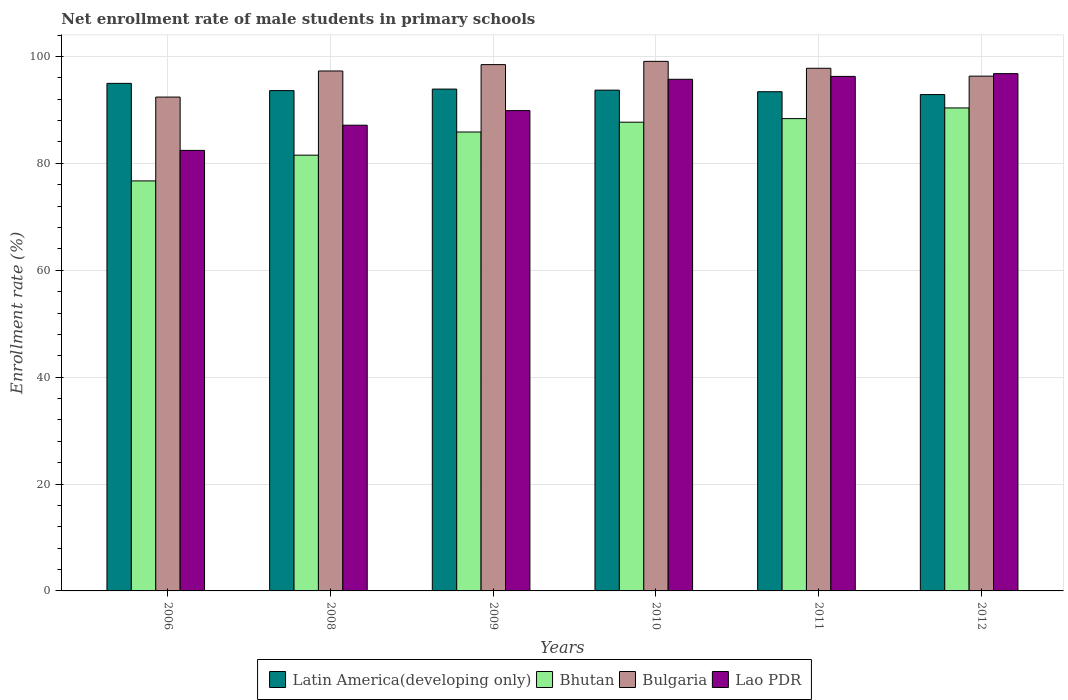How many groups of bars are there?
Your response must be concise. 6. How many bars are there on the 4th tick from the right?
Provide a short and direct response. 4. What is the net enrollment rate of male students in primary schools in Lao PDR in 2012?
Offer a very short reply. 96.79. Across all years, what is the maximum net enrollment rate of male students in primary schools in Bhutan?
Your answer should be compact. 90.37. Across all years, what is the minimum net enrollment rate of male students in primary schools in Lao PDR?
Offer a very short reply. 82.43. In which year was the net enrollment rate of male students in primary schools in Latin America(developing only) maximum?
Provide a short and direct response. 2006. What is the total net enrollment rate of male students in primary schools in Lao PDR in the graph?
Your response must be concise. 548.23. What is the difference between the net enrollment rate of male students in primary schools in Bhutan in 2006 and that in 2012?
Give a very brief answer. -13.65. What is the difference between the net enrollment rate of male students in primary schools in Lao PDR in 2010 and the net enrollment rate of male students in primary schools in Latin America(developing only) in 2006?
Your response must be concise. 0.76. What is the average net enrollment rate of male students in primary schools in Bulgaria per year?
Offer a terse response. 96.89. In the year 2006, what is the difference between the net enrollment rate of male students in primary schools in Latin America(developing only) and net enrollment rate of male students in primary schools in Lao PDR?
Your response must be concise. 12.54. What is the ratio of the net enrollment rate of male students in primary schools in Latin America(developing only) in 2009 to that in 2012?
Ensure brevity in your answer.  1.01. What is the difference between the highest and the second highest net enrollment rate of male students in primary schools in Bhutan?
Ensure brevity in your answer.  2. What is the difference between the highest and the lowest net enrollment rate of male students in primary schools in Bulgaria?
Offer a terse response. 6.68. In how many years, is the net enrollment rate of male students in primary schools in Bulgaria greater than the average net enrollment rate of male students in primary schools in Bulgaria taken over all years?
Keep it short and to the point. 4. Is the sum of the net enrollment rate of male students in primary schools in Lao PDR in 2006 and 2010 greater than the maximum net enrollment rate of male students in primary schools in Bulgaria across all years?
Your answer should be very brief. Yes. What does the 4th bar from the left in 2010 represents?
Offer a very short reply. Lao PDR. What does the 1st bar from the right in 2009 represents?
Ensure brevity in your answer.  Lao PDR. How many years are there in the graph?
Ensure brevity in your answer.  6. What is the difference between two consecutive major ticks on the Y-axis?
Your answer should be very brief. 20. Does the graph contain any zero values?
Make the answer very short. No. How many legend labels are there?
Offer a very short reply. 4. What is the title of the graph?
Provide a short and direct response. Net enrollment rate of male students in primary schools. Does "Congo (Democratic)" appear as one of the legend labels in the graph?
Provide a succinct answer. No. What is the label or title of the Y-axis?
Ensure brevity in your answer.  Enrollment rate (%). What is the Enrollment rate (%) of Latin America(developing only) in 2006?
Your response must be concise. 94.97. What is the Enrollment rate (%) of Bhutan in 2006?
Your answer should be very brief. 76.72. What is the Enrollment rate (%) in Bulgaria in 2006?
Make the answer very short. 92.4. What is the Enrollment rate (%) in Lao PDR in 2006?
Ensure brevity in your answer.  82.43. What is the Enrollment rate (%) of Latin America(developing only) in 2008?
Your response must be concise. 93.62. What is the Enrollment rate (%) in Bhutan in 2008?
Provide a succinct answer. 81.53. What is the Enrollment rate (%) of Bulgaria in 2008?
Provide a succinct answer. 97.29. What is the Enrollment rate (%) in Lao PDR in 2008?
Keep it short and to the point. 87.14. What is the Enrollment rate (%) of Latin America(developing only) in 2009?
Give a very brief answer. 93.9. What is the Enrollment rate (%) of Bhutan in 2009?
Make the answer very short. 85.87. What is the Enrollment rate (%) in Bulgaria in 2009?
Your answer should be compact. 98.48. What is the Enrollment rate (%) of Lao PDR in 2009?
Provide a short and direct response. 89.87. What is the Enrollment rate (%) in Latin America(developing only) in 2010?
Offer a terse response. 93.7. What is the Enrollment rate (%) of Bhutan in 2010?
Offer a very short reply. 87.7. What is the Enrollment rate (%) in Bulgaria in 2010?
Ensure brevity in your answer.  99.09. What is the Enrollment rate (%) in Lao PDR in 2010?
Your response must be concise. 95.73. What is the Enrollment rate (%) of Latin America(developing only) in 2011?
Your answer should be compact. 93.4. What is the Enrollment rate (%) of Bhutan in 2011?
Keep it short and to the point. 88.37. What is the Enrollment rate (%) of Bulgaria in 2011?
Provide a short and direct response. 97.79. What is the Enrollment rate (%) in Lao PDR in 2011?
Give a very brief answer. 96.27. What is the Enrollment rate (%) of Latin America(developing only) in 2012?
Your answer should be compact. 92.87. What is the Enrollment rate (%) of Bhutan in 2012?
Your answer should be very brief. 90.37. What is the Enrollment rate (%) of Bulgaria in 2012?
Ensure brevity in your answer.  96.32. What is the Enrollment rate (%) in Lao PDR in 2012?
Keep it short and to the point. 96.79. Across all years, what is the maximum Enrollment rate (%) of Latin America(developing only)?
Your answer should be compact. 94.97. Across all years, what is the maximum Enrollment rate (%) in Bhutan?
Provide a short and direct response. 90.37. Across all years, what is the maximum Enrollment rate (%) of Bulgaria?
Give a very brief answer. 99.09. Across all years, what is the maximum Enrollment rate (%) of Lao PDR?
Your answer should be very brief. 96.79. Across all years, what is the minimum Enrollment rate (%) of Latin America(developing only)?
Your answer should be compact. 92.87. Across all years, what is the minimum Enrollment rate (%) in Bhutan?
Keep it short and to the point. 76.72. Across all years, what is the minimum Enrollment rate (%) in Bulgaria?
Offer a very short reply. 92.4. Across all years, what is the minimum Enrollment rate (%) in Lao PDR?
Provide a short and direct response. 82.43. What is the total Enrollment rate (%) of Latin America(developing only) in the graph?
Keep it short and to the point. 562.46. What is the total Enrollment rate (%) of Bhutan in the graph?
Offer a very short reply. 510.57. What is the total Enrollment rate (%) of Bulgaria in the graph?
Make the answer very short. 581.37. What is the total Enrollment rate (%) of Lao PDR in the graph?
Your response must be concise. 548.23. What is the difference between the Enrollment rate (%) of Latin America(developing only) in 2006 and that in 2008?
Keep it short and to the point. 1.35. What is the difference between the Enrollment rate (%) of Bhutan in 2006 and that in 2008?
Offer a very short reply. -4.82. What is the difference between the Enrollment rate (%) of Bulgaria in 2006 and that in 2008?
Your response must be concise. -4.88. What is the difference between the Enrollment rate (%) of Lao PDR in 2006 and that in 2008?
Your answer should be very brief. -4.71. What is the difference between the Enrollment rate (%) in Latin America(developing only) in 2006 and that in 2009?
Give a very brief answer. 1.07. What is the difference between the Enrollment rate (%) of Bhutan in 2006 and that in 2009?
Give a very brief answer. -9.15. What is the difference between the Enrollment rate (%) of Bulgaria in 2006 and that in 2009?
Provide a succinct answer. -6.07. What is the difference between the Enrollment rate (%) of Lao PDR in 2006 and that in 2009?
Ensure brevity in your answer.  -7.44. What is the difference between the Enrollment rate (%) in Latin America(developing only) in 2006 and that in 2010?
Provide a succinct answer. 1.27. What is the difference between the Enrollment rate (%) of Bhutan in 2006 and that in 2010?
Offer a very short reply. -10.98. What is the difference between the Enrollment rate (%) of Bulgaria in 2006 and that in 2010?
Provide a succinct answer. -6.68. What is the difference between the Enrollment rate (%) of Lao PDR in 2006 and that in 2010?
Your answer should be compact. -13.3. What is the difference between the Enrollment rate (%) in Latin America(developing only) in 2006 and that in 2011?
Offer a terse response. 1.56. What is the difference between the Enrollment rate (%) in Bhutan in 2006 and that in 2011?
Offer a terse response. -11.66. What is the difference between the Enrollment rate (%) of Bulgaria in 2006 and that in 2011?
Your answer should be compact. -5.39. What is the difference between the Enrollment rate (%) of Lao PDR in 2006 and that in 2011?
Your response must be concise. -13.84. What is the difference between the Enrollment rate (%) in Latin America(developing only) in 2006 and that in 2012?
Give a very brief answer. 2.1. What is the difference between the Enrollment rate (%) of Bhutan in 2006 and that in 2012?
Offer a very short reply. -13.65. What is the difference between the Enrollment rate (%) of Bulgaria in 2006 and that in 2012?
Make the answer very short. -3.92. What is the difference between the Enrollment rate (%) in Lao PDR in 2006 and that in 2012?
Your response must be concise. -14.36. What is the difference between the Enrollment rate (%) in Latin America(developing only) in 2008 and that in 2009?
Provide a succinct answer. -0.28. What is the difference between the Enrollment rate (%) in Bhutan in 2008 and that in 2009?
Offer a terse response. -4.33. What is the difference between the Enrollment rate (%) of Bulgaria in 2008 and that in 2009?
Ensure brevity in your answer.  -1.19. What is the difference between the Enrollment rate (%) in Lao PDR in 2008 and that in 2009?
Provide a short and direct response. -2.73. What is the difference between the Enrollment rate (%) in Latin America(developing only) in 2008 and that in 2010?
Make the answer very short. -0.09. What is the difference between the Enrollment rate (%) of Bhutan in 2008 and that in 2010?
Offer a very short reply. -6.17. What is the difference between the Enrollment rate (%) of Bulgaria in 2008 and that in 2010?
Your answer should be compact. -1.8. What is the difference between the Enrollment rate (%) in Lao PDR in 2008 and that in 2010?
Provide a short and direct response. -8.59. What is the difference between the Enrollment rate (%) of Latin America(developing only) in 2008 and that in 2011?
Offer a very short reply. 0.21. What is the difference between the Enrollment rate (%) of Bhutan in 2008 and that in 2011?
Your response must be concise. -6.84. What is the difference between the Enrollment rate (%) in Bulgaria in 2008 and that in 2011?
Your answer should be compact. -0.51. What is the difference between the Enrollment rate (%) of Lao PDR in 2008 and that in 2011?
Ensure brevity in your answer.  -9.13. What is the difference between the Enrollment rate (%) in Latin America(developing only) in 2008 and that in 2012?
Offer a terse response. 0.74. What is the difference between the Enrollment rate (%) in Bhutan in 2008 and that in 2012?
Provide a succinct answer. -8.84. What is the difference between the Enrollment rate (%) of Bulgaria in 2008 and that in 2012?
Your answer should be compact. 0.97. What is the difference between the Enrollment rate (%) in Lao PDR in 2008 and that in 2012?
Make the answer very short. -9.65. What is the difference between the Enrollment rate (%) of Latin America(developing only) in 2009 and that in 2010?
Your answer should be compact. 0.2. What is the difference between the Enrollment rate (%) of Bhutan in 2009 and that in 2010?
Provide a succinct answer. -1.84. What is the difference between the Enrollment rate (%) of Bulgaria in 2009 and that in 2010?
Your answer should be compact. -0.61. What is the difference between the Enrollment rate (%) in Lao PDR in 2009 and that in 2010?
Your answer should be compact. -5.86. What is the difference between the Enrollment rate (%) of Latin America(developing only) in 2009 and that in 2011?
Offer a terse response. 0.49. What is the difference between the Enrollment rate (%) of Bhutan in 2009 and that in 2011?
Offer a very short reply. -2.51. What is the difference between the Enrollment rate (%) in Bulgaria in 2009 and that in 2011?
Your response must be concise. 0.68. What is the difference between the Enrollment rate (%) of Lao PDR in 2009 and that in 2011?
Your response must be concise. -6.4. What is the difference between the Enrollment rate (%) of Latin America(developing only) in 2009 and that in 2012?
Your response must be concise. 1.03. What is the difference between the Enrollment rate (%) of Bhutan in 2009 and that in 2012?
Provide a short and direct response. -4.51. What is the difference between the Enrollment rate (%) in Bulgaria in 2009 and that in 2012?
Keep it short and to the point. 2.16. What is the difference between the Enrollment rate (%) in Lao PDR in 2009 and that in 2012?
Keep it short and to the point. -6.92. What is the difference between the Enrollment rate (%) of Latin America(developing only) in 2010 and that in 2011?
Provide a short and direct response. 0.3. What is the difference between the Enrollment rate (%) of Bhutan in 2010 and that in 2011?
Your answer should be compact. -0.67. What is the difference between the Enrollment rate (%) in Bulgaria in 2010 and that in 2011?
Your response must be concise. 1.29. What is the difference between the Enrollment rate (%) in Lao PDR in 2010 and that in 2011?
Your answer should be compact. -0.54. What is the difference between the Enrollment rate (%) of Latin America(developing only) in 2010 and that in 2012?
Offer a terse response. 0.83. What is the difference between the Enrollment rate (%) in Bhutan in 2010 and that in 2012?
Give a very brief answer. -2.67. What is the difference between the Enrollment rate (%) of Bulgaria in 2010 and that in 2012?
Your answer should be compact. 2.77. What is the difference between the Enrollment rate (%) of Lao PDR in 2010 and that in 2012?
Your answer should be very brief. -1.06. What is the difference between the Enrollment rate (%) in Latin America(developing only) in 2011 and that in 2012?
Provide a short and direct response. 0.53. What is the difference between the Enrollment rate (%) in Bhutan in 2011 and that in 2012?
Your answer should be very brief. -2. What is the difference between the Enrollment rate (%) in Bulgaria in 2011 and that in 2012?
Keep it short and to the point. 1.47. What is the difference between the Enrollment rate (%) of Lao PDR in 2011 and that in 2012?
Provide a short and direct response. -0.52. What is the difference between the Enrollment rate (%) of Latin America(developing only) in 2006 and the Enrollment rate (%) of Bhutan in 2008?
Keep it short and to the point. 13.44. What is the difference between the Enrollment rate (%) in Latin America(developing only) in 2006 and the Enrollment rate (%) in Bulgaria in 2008?
Provide a succinct answer. -2.32. What is the difference between the Enrollment rate (%) of Latin America(developing only) in 2006 and the Enrollment rate (%) of Lao PDR in 2008?
Your response must be concise. 7.83. What is the difference between the Enrollment rate (%) in Bhutan in 2006 and the Enrollment rate (%) in Bulgaria in 2008?
Your answer should be compact. -20.57. What is the difference between the Enrollment rate (%) of Bhutan in 2006 and the Enrollment rate (%) of Lao PDR in 2008?
Give a very brief answer. -10.42. What is the difference between the Enrollment rate (%) in Bulgaria in 2006 and the Enrollment rate (%) in Lao PDR in 2008?
Provide a short and direct response. 5.26. What is the difference between the Enrollment rate (%) in Latin America(developing only) in 2006 and the Enrollment rate (%) in Bhutan in 2009?
Make the answer very short. 9.1. What is the difference between the Enrollment rate (%) of Latin America(developing only) in 2006 and the Enrollment rate (%) of Bulgaria in 2009?
Give a very brief answer. -3.51. What is the difference between the Enrollment rate (%) in Latin America(developing only) in 2006 and the Enrollment rate (%) in Lao PDR in 2009?
Offer a terse response. 5.1. What is the difference between the Enrollment rate (%) in Bhutan in 2006 and the Enrollment rate (%) in Bulgaria in 2009?
Make the answer very short. -21.76. What is the difference between the Enrollment rate (%) in Bhutan in 2006 and the Enrollment rate (%) in Lao PDR in 2009?
Your response must be concise. -13.15. What is the difference between the Enrollment rate (%) in Bulgaria in 2006 and the Enrollment rate (%) in Lao PDR in 2009?
Keep it short and to the point. 2.53. What is the difference between the Enrollment rate (%) of Latin America(developing only) in 2006 and the Enrollment rate (%) of Bhutan in 2010?
Your response must be concise. 7.27. What is the difference between the Enrollment rate (%) of Latin America(developing only) in 2006 and the Enrollment rate (%) of Bulgaria in 2010?
Ensure brevity in your answer.  -4.12. What is the difference between the Enrollment rate (%) of Latin America(developing only) in 2006 and the Enrollment rate (%) of Lao PDR in 2010?
Make the answer very short. -0.76. What is the difference between the Enrollment rate (%) in Bhutan in 2006 and the Enrollment rate (%) in Bulgaria in 2010?
Ensure brevity in your answer.  -22.37. What is the difference between the Enrollment rate (%) in Bhutan in 2006 and the Enrollment rate (%) in Lao PDR in 2010?
Your answer should be very brief. -19.01. What is the difference between the Enrollment rate (%) in Bulgaria in 2006 and the Enrollment rate (%) in Lao PDR in 2010?
Offer a very short reply. -3.33. What is the difference between the Enrollment rate (%) of Latin America(developing only) in 2006 and the Enrollment rate (%) of Bhutan in 2011?
Provide a short and direct response. 6.6. What is the difference between the Enrollment rate (%) of Latin America(developing only) in 2006 and the Enrollment rate (%) of Bulgaria in 2011?
Ensure brevity in your answer.  -2.82. What is the difference between the Enrollment rate (%) of Latin America(developing only) in 2006 and the Enrollment rate (%) of Lao PDR in 2011?
Make the answer very short. -1.3. What is the difference between the Enrollment rate (%) of Bhutan in 2006 and the Enrollment rate (%) of Bulgaria in 2011?
Your answer should be very brief. -21.07. What is the difference between the Enrollment rate (%) of Bhutan in 2006 and the Enrollment rate (%) of Lao PDR in 2011?
Give a very brief answer. -19.55. What is the difference between the Enrollment rate (%) of Bulgaria in 2006 and the Enrollment rate (%) of Lao PDR in 2011?
Your answer should be compact. -3.87. What is the difference between the Enrollment rate (%) in Latin America(developing only) in 2006 and the Enrollment rate (%) in Bhutan in 2012?
Make the answer very short. 4.6. What is the difference between the Enrollment rate (%) of Latin America(developing only) in 2006 and the Enrollment rate (%) of Bulgaria in 2012?
Make the answer very short. -1.35. What is the difference between the Enrollment rate (%) in Latin America(developing only) in 2006 and the Enrollment rate (%) in Lao PDR in 2012?
Give a very brief answer. -1.82. What is the difference between the Enrollment rate (%) in Bhutan in 2006 and the Enrollment rate (%) in Bulgaria in 2012?
Your answer should be very brief. -19.6. What is the difference between the Enrollment rate (%) in Bhutan in 2006 and the Enrollment rate (%) in Lao PDR in 2012?
Ensure brevity in your answer.  -20.07. What is the difference between the Enrollment rate (%) of Bulgaria in 2006 and the Enrollment rate (%) of Lao PDR in 2012?
Give a very brief answer. -4.39. What is the difference between the Enrollment rate (%) in Latin America(developing only) in 2008 and the Enrollment rate (%) in Bhutan in 2009?
Your answer should be very brief. 7.75. What is the difference between the Enrollment rate (%) of Latin America(developing only) in 2008 and the Enrollment rate (%) of Bulgaria in 2009?
Offer a terse response. -4.86. What is the difference between the Enrollment rate (%) in Latin America(developing only) in 2008 and the Enrollment rate (%) in Lao PDR in 2009?
Offer a terse response. 3.75. What is the difference between the Enrollment rate (%) of Bhutan in 2008 and the Enrollment rate (%) of Bulgaria in 2009?
Provide a short and direct response. -16.94. What is the difference between the Enrollment rate (%) of Bhutan in 2008 and the Enrollment rate (%) of Lao PDR in 2009?
Your response must be concise. -8.34. What is the difference between the Enrollment rate (%) in Bulgaria in 2008 and the Enrollment rate (%) in Lao PDR in 2009?
Make the answer very short. 7.42. What is the difference between the Enrollment rate (%) of Latin America(developing only) in 2008 and the Enrollment rate (%) of Bhutan in 2010?
Ensure brevity in your answer.  5.91. What is the difference between the Enrollment rate (%) of Latin America(developing only) in 2008 and the Enrollment rate (%) of Bulgaria in 2010?
Offer a very short reply. -5.47. What is the difference between the Enrollment rate (%) in Latin America(developing only) in 2008 and the Enrollment rate (%) in Lao PDR in 2010?
Offer a very short reply. -2.12. What is the difference between the Enrollment rate (%) in Bhutan in 2008 and the Enrollment rate (%) in Bulgaria in 2010?
Provide a succinct answer. -17.55. What is the difference between the Enrollment rate (%) of Bhutan in 2008 and the Enrollment rate (%) of Lao PDR in 2010?
Provide a short and direct response. -14.2. What is the difference between the Enrollment rate (%) of Bulgaria in 2008 and the Enrollment rate (%) of Lao PDR in 2010?
Ensure brevity in your answer.  1.56. What is the difference between the Enrollment rate (%) in Latin America(developing only) in 2008 and the Enrollment rate (%) in Bhutan in 2011?
Offer a terse response. 5.24. What is the difference between the Enrollment rate (%) of Latin America(developing only) in 2008 and the Enrollment rate (%) of Bulgaria in 2011?
Your answer should be very brief. -4.18. What is the difference between the Enrollment rate (%) of Latin America(developing only) in 2008 and the Enrollment rate (%) of Lao PDR in 2011?
Your answer should be compact. -2.66. What is the difference between the Enrollment rate (%) of Bhutan in 2008 and the Enrollment rate (%) of Bulgaria in 2011?
Make the answer very short. -16.26. What is the difference between the Enrollment rate (%) in Bhutan in 2008 and the Enrollment rate (%) in Lao PDR in 2011?
Your response must be concise. -14.74. What is the difference between the Enrollment rate (%) in Latin America(developing only) in 2008 and the Enrollment rate (%) in Bhutan in 2012?
Your answer should be compact. 3.24. What is the difference between the Enrollment rate (%) in Latin America(developing only) in 2008 and the Enrollment rate (%) in Bulgaria in 2012?
Offer a terse response. -2.7. What is the difference between the Enrollment rate (%) of Latin America(developing only) in 2008 and the Enrollment rate (%) of Lao PDR in 2012?
Provide a short and direct response. -3.17. What is the difference between the Enrollment rate (%) in Bhutan in 2008 and the Enrollment rate (%) in Bulgaria in 2012?
Keep it short and to the point. -14.79. What is the difference between the Enrollment rate (%) in Bhutan in 2008 and the Enrollment rate (%) in Lao PDR in 2012?
Provide a short and direct response. -15.26. What is the difference between the Enrollment rate (%) of Bulgaria in 2008 and the Enrollment rate (%) of Lao PDR in 2012?
Keep it short and to the point. 0.5. What is the difference between the Enrollment rate (%) in Latin America(developing only) in 2009 and the Enrollment rate (%) in Bhutan in 2010?
Your answer should be compact. 6.2. What is the difference between the Enrollment rate (%) in Latin America(developing only) in 2009 and the Enrollment rate (%) in Bulgaria in 2010?
Ensure brevity in your answer.  -5.19. What is the difference between the Enrollment rate (%) of Latin America(developing only) in 2009 and the Enrollment rate (%) of Lao PDR in 2010?
Your answer should be compact. -1.83. What is the difference between the Enrollment rate (%) in Bhutan in 2009 and the Enrollment rate (%) in Bulgaria in 2010?
Your answer should be very brief. -13.22. What is the difference between the Enrollment rate (%) of Bhutan in 2009 and the Enrollment rate (%) of Lao PDR in 2010?
Your response must be concise. -9.87. What is the difference between the Enrollment rate (%) in Bulgaria in 2009 and the Enrollment rate (%) in Lao PDR in 2010?
Give a very brief answer. 2.75. What is the difference between the Enrollment rate (%) of Latin America(developing only) in 2009 and the Enrollment rate (%) of Bhutan in 2011?
Make the answer very short. 5.53. What is the difference between the Enrollment rate (%) in Latin America(developing only) in 2009 and the Enrollment rate (%) in Bulgaria in 2011?
Provide a succinct answer. -3.89. What is the difference between the Enrollment rate (%) in Latin America(developing only) in 2009 and the Enrollment rate (%) in Lao PDR in 2011?
Offer a terse response. -2.37. What is the difference between the Enrollment rate (%) of Bhutan in 2009 and the Enrollment rate (%) of Bulgaria in 2011?
Ensure brevity in your answer.  -11.93. What is the difference between the Enrollment rate (%) in Bhutan in 2009 and the Enrollment rate (%) in Lao PDR in 2011?
Make the answer very short. -10.41. What is the difference between the Enrollment rate (%) in Bulgaria in 2009 and the Enrollment rate (%) in Lao PDR in 2011?
Your answer should be compact. 2.2. What is the difference between the Enrollment rate (%) in Latin America(developing only) in 2009 and the Enrollment rate (%) in Bhutan in 2012?
Give a very brief answer. 3.53. What is the difference between the Enrollment rate (%) of Latin America(developing only) in 2009 and the Enrollment rate (%) of Bulgaria in 2012?
Offer a very short reply. -2.42. What is the difference between the Enrollment rate (%) in Latin America(developing only) in 2009 and the Enrollment rate (%) in Lao PDR in 2012?
Offer a very short reply. -2.89. What is the difference between the Enrollment rate (%) in Bhutan in 2009 and the Enrollment rate (%) in Bulgaria in 2012?
Your answer should be very brief. -10.45. What is the difference between the Enrollment rate (%) of Bhutan in 2009 and the Enrollment rate (%) of Lao PDR in 2012?
Offer a terse response. -10.92. What is the difference between the Enrollment rate (%) of Bulgaria in 2009 and the Enrollment rate (%) of Lao PDR in 2012?
Offer a very short reply. 1.69. What is the difference between the Enrollment rate (%) in Latin America(developing only) in 2010 and the Enrollment rate (%) in Bhutan in 2011?
Your response must be concise. 5.33. What is the difference between the Enrollment rate (%) in Latin America(developing only) in 2010 and the Enrollment rate (%) in Bulgaria in 2011?
Provide a succinct answer. -4.09. What is the difference between the Enrollment rate (%) in Latin America(developing only) in 2010 and the Enrollment rate (%) in Lao PDR in 2011?
Keep it short and to the point. -2.57. What is the difference between the Enrollment rate (%) in Bhutan in 2010 and the Enrollment rate (%) in Bulgaria in 2011?
Give a very brief answer. -10.09. What is the difference between the Enrollment rate (%) of Bhutan in 2010 and the Enrollment rate (%) of Lao PDR in 2011?
Your response must be concise. -8.57. What is the difference between the Enrollment rate (%) of Bulgaria in 2010 and the Enrollment rate (%) of Lao PDR in 2011?
Keep it short and to the point. 2.82. What is the difference between the Enrollment rate (%) of Latin America(developing only) in 2010 and the Enrollment rate (%) of Bhutan in 2012?
Ensure brevity in your answer.  3.33. What is the difference between the Enrollment rate (%) in Latin America(developing only) in 2010 and the Enrollment rate (%) in Bulgaria in 2012?
Give a very brief answer. -2.62. What is the difference between the Enrollment rate (%) of Latin America(developing only) in 2010 and the Enrollment rate (%) of Lao PDR in 2012?
Your answer should be compact. -3.09. What is the difference between the Enrollment rate (%) of Bhutan in 2010 and the Enrollment rate (%) of Bulgaria in 2012?
Provide a succinct answer. -8.62. What is the difference between the Enrollment rate (%) of Bhutan in 2010 and the Enrollment rate (%) of Lao PDR in 2012?
Provide a succinct answer. -9.09. What is the difference between the Enrollment rate (%) of Bulgaria in 2010 and the Enrollment rate (%) of Lao PDR in 2012?
Your response must be concise. 2.3. What is the difference between the Enrollment rate (%) in Latin America(developing only) in 2011 and the Enrollment rate (%) in Bhutan in 2012?
Offer a very short reply. 3.03. What is the difference between the Enrollment rate (%) in Latin America(developing only) in 2011 and the Enrollment rate (%) in Bulgaria in 2012?
Your response must be concise. -2.91. What is the difference between the Enrollment rate (%) of Latin America(developing only) in 2011 and the Enrollment rate (%) of Lao PDR in 2012?
Make the answer very short. -3.39. What is the difference between the Enrollment rate (%) of Bhutan in 2011 and the Enrollment rate (%) of Bulgaria in 2012?
Your answer should be compact. -7.95. What is the difference between the Enrollment rate (%) in Bhutan in 2011 and the Enrollment rate (%) in Lao PDR in 2012?
Make the answer very short. -8.42. What is the average Enrollment rate (%) in Latin America(developing only) per year?
Give a very brief answer. 93.74. What is the average Enrollment rate (%) in Bhutan per year?
Give a very brief answer. 85.09. What is the average Enrollment rate (%) in Bulgaria per year?
Offer a terse response. 96.89. What is the average Enrollment rate (%) of Lao PDR per year?
Your answer should be compact. 91.37. In the year 2006, what is the difference between the Enrollment rate (%) in Latin America(developing only) and Enrollment rate (%) in Bhutan?
Your response must be concise. 18.25. In the year 2006, what is the difference between the Enrollment rate (%) in Latin America(developing only) and Enrollment rate (%) in Bulgaria?
Provide a succinct answer. 2.57. In the year 2006, what is the difference between the Enrollment rate (%) in Latin America(developing only) and Enrollment rate (%) in Lao PDR?
Provide a short and direct response. 12.54. In the year 2006, what is the difference between the Enrollment rate (%) of Bhutan and Enrollment rate (%) of Bulgaria?
Provide a short and direct response. -15.68. In the year 2006, what is the difference between the Enrollment rate (%) of Bhutan and Enrollment rate (%) of Lao PDR?
Offer a very short reply. -5.71. In the year 2006, what is the difference between the Enrollment rate (%) of Bulgaria and Enrollment rate (%) of Lao PDR?
Your response must be concise. 9.98. In the year 2008, what is the difference between the Enrollment rate (%) in Latin America(developing only) and Enrollment rate (%) in Bhutan?
Make the answer very short. 12.08. In the year 2008, what is the difference between the Enrollment rate (%) of Latin America(developing only) and Enrollment rate (%) of Bulgaria?
Your response must be concise. -3.67. In the year 2008, what is the difference between the Enrollment rate (%) of Latin America(developing only) and Enrollment rate (%) of Lao PDR?
Give a very brief answer. 6.47. In the year 2008, what is the difference between the Enrollment rate (%) in Bhutan and Enrollment rate (%) in Bulgaria?
Keep it short and to the point. -15.75. In the year 2008, what is the difference between the Enrollment rate (%) in Bhutan and Enrollment rate (%) in Lao PDR?
Ensure brevity in your answer.  -5.61. In the year 2008, what is the difference between the Enrollment rate (%) in Bulgaria and Enrollment rate (%) in Lao PDR?
Provide a short and direct response. 10.15. In the year 2009, what is the difference between the Enrollment rate (%) in Latin America(developing only) and Enrollment rate (%) in Bhutan?
Keep it short and to the point. 8.03. In the year 2009, what is the difference between the Enrollment rate (%) of Latin America(developing only) and Enrollment rate (%) of Bulgaria?
Give a very brief answer. -4.58. In the year 2009, what is the difference between the Enrollment rate (%) in Latin America(developing only) and Enrollment rate (%) in Lao PDR?
Make the answer very short. 4.03. In the year 2009, what is the difference between the Enrollment rate (%) of Bhutan and Enrollment rate (%) of Bulgaria?
Make the answer very short. -12.61. In the year 2009, what is the difference between the Enrollment rate (%) of Bhutan and Enrollment rate (%) of Lao PDR?
Provide a short and direct response. -4. In the year 2009, what is the difference between the Enrollment rate (%) in Bulgaria and Enrollment rate (%) in Lao PDR?
Provide a succinct answer. 8.61. In the year 2010, what is the difference between the Enrollment rate (%) of Latin America(developing only) and Enrollment rate (%) of Bhutan?
Your answer should be compact. 6. In the year 2010, what is the difference between the Enrollment rate (%) of Latin America(developing only) and Enrollment rate (%) of Bulgaria?
Your answer should be very brief. -5.39. In the year 2010, what is the difference between the Enrollment rate (%) in Latin America(developing only) and Enrollment rate (%) in Lao PDR?
Your answer should be compact. -2.03. In the year 2010, what is the difference between the Enrollment rate (%) in Bhutan and Enrollment rate (%) in Bulgaria?
Your answer should be compact. -11.39. In the year 2010, what is the difference between the Enrollment rate (%) of Bhutan and Enrollment rate (%) of Lao PDR?
Give a very brief answer. -8.03. In the year 2010, what is the difference between the Enrollment rate (%) of Bulgaria and Enrollment rate (%) of Lao PDR?
Offer a terse response. 3.36. In the year 2011, what is the difference between the Enrollment rate (%) in Latin America(developing only) and Enrollment rate (%) in Bhutan?
Offer a very short reply. 5.03. In the year 2011, what is the difference between the Enrollment rate (%) of Latin America(developing only) and Enrollment rate (%) of Bulgaria?
Offer a terse response. -4.39. In the year 2011, what is the difference between the Enrollment rate (%) in Latin America(developing only) and Enrollment rate (%) in Lao PDR?
Your answer should be compact. -2.87. In the year 2011, what is the difference between the Enrollment rate (%) of Bhutan and Enrollment rate (%) of Bulgaria?
Your answer should be compact. -9.42. In the year 2011, what is the difference between the Enrollment rate (%) of Bhutan and Enrollment rate (%) of Lao PDR?
Make the answer very short. -7.9. In the year 2011, what is the difference between the Enrollment rate (%) of Bulgaria and Enrollment rate (%) of Lao PDR?
Provide a short and direct response. 1.52. In the year 2012, what is the difference between the Enrollment rate (%) in Latin America(developing only) and Enrollment rate (%) in Bhutan?
Give a very brief answer. 2.5. In the year 2012, what is the difference between the Enrollment rate (%) in Latin America(developing only) and Enrollment rate (%) in Bulgaria?
Offer a terse response. -3.45. In the year 2012, what is the difference between the Enrollment rate (%) of Latin America(developing only) and Enrollment rate (%) of Lao PDR?
Your response must be concise. -3.92. In the year 2012, what is the difference between the Enrollment rate (%) in Bhutan and Enrollment rate (%) in Bulgaria?
Make the answer very short. -5.95. In the year 2012, what is the difference between the Enrollment rate (%) in Bhutan and Enrollment rate (%) in Lao PDR?
Give a very brief answer. -6.42. In the year 2012, what is the difference between the Enrollment rate (%) in Bulgaria and Enrollment rate (%) in Lao PDR?
Give a very brief answer. -0.47. What is the ratio of the Enrollment rate (%) of Latin America(developing only) in 2006 to that in 2008?
Ensure brevity in your answer.  1.01. What is the ratio of the Enrollment rate (%) in Bhutan in 2006 to that in 2008?
Your answer should be compact. 0.94. What is the ratio of the Enrollment rate (%) of Bulgaria in 2006 to that in 2008?
Your response must be concise. 0.95. What is the ratio of the Enrollment rate (%) of Lao PDR in 2006 to that in 2008?
Provide a short and direct response. 0.95. What is the ratio of the Enrollment rate (%) of Latin America(developing only) in 2006 to that in 2009?
Your response must be concise. 1.01. What is the ratio of the Enrollment rate (%) in Bhutan in 2006 to that in 2009?
Make the answer very short. 0.89. What is the ratio of the Enrollment rate (%) in Bulgaria in 2006 to that in 2009?
Your answer should be compact. 0.94. What is the ratio of the Enrollment rate (%) in Lao PDR in 2006 to that in 2009?
Make the answer very short. 0.92. What is the ratio of the Enrollment rate (%) in Latin America(developing only) in 2006 to that in 2010?
Your answer should be compact. 1.01. What is the ratio of the Enrollment rate (%) of Bhutan in 2006 to that in 2010?
Give a very brief answer. 0.87. What is the ratio of the Enrollment rate (%) in Bulgaria in 2006 to that in 2010?
Provide a succinct answer. 0.93. What is the ratio of the Enrollment rate (%) of Lao PDR in 2006 to that in 2010?
Keep it short and to the point. 0.86. What is the ratio of the Enrollment rate (%) of Latin America(developing only) in 2006 to that in 2011?
Your response must be concise. 1.02. What is the ratio of the Enrollment rate (%) in Bhutan in 2006 to that in 2011?
Make the answer very short. 0.87. What is the ratio of the Enrollment rate (%) in Bulgaria in 2006 to that in 2011?
Offer a very short reply. 0.94. What is the ratio of the Enrollment rate (%) in Lao PDR in 2006 to that in 2011?
Your response must be concise. 0.86. What is the ratio of the Enrollment rate (%) of Latin America(developing only) in 2006 to that in 2012?
Your answer should be very brief. 1.02. What is the ratio of the Enrollment rate (%) of Bhutan in 2006 to that in 2012?
Your response must be concise. 0.85. What is the ratio of the Enrollment rate (%) in Bulgaria in 2006 to that in 2012?
Offer a very short reply. 0.96. What is the ratio of the Enrollment rate (%) in Lao PDR in 2006 to that in 2012?
Your answer should be compact. 0.85. What is the ratio of the Enrollment rate (%) in Latin America(developing only) in 2008 to that in 2009?
Your response must be concise. 1. What is the ratio of the Enrollment rate (%) of Bhutan in 2008 to that in 2009?
Offer a terse response. 0.95. What is the ratio of the Enrollment rate (%) in Bulgaria in 2008 to that in 2009?
Make the answer very short. 0.99. What is the ratio of the Enrollment rate (%) of Lao PDR in 2008 to that in 2009?
Provide a short and direct response. 0.97. What is the ratio of the Enrollment rate (%) in Latin America(developing only) in 2008 to that in 2010?
Provide a succinct answer. 1. What is the ratio of the Enrollment rate (%) of Bhutan in 2008 to that in 2010?
Your answer should be very brief. 0.93. What is the ratio of the Enrollment rate (%) of Bulgaria in 2008 to that in 2010?
Provide a succinct answer. 0.98. What is the ratio of the Enrollment rate (%) in Lao PDR in 2008 to that in 2010?
Give a very brief answer. 0.91. What is the ratio of the Enrollment rate (%) of Latin America(developing only) in 2008 to that in 2011?
Your answer should be very brief. 1. What is the ratio of the Enrollment rate (%) in Bhutan in 2008 to that in 2011?
Give a very brief answer. 0.92. What is the ratio of the Enrollment rate (%) in Bulgaria in 2008 to that in 2011?
Your answer should be very brief. 0.99. What is the ratio of the Enrollment rate (%) of Lao PDR in 2008 to that in 2011?
Offer a very short reply. 0.91. What is the ratio of the Enrollment rate (%) of Latin America(developing only) in 2008 to that in 2012?
Your answer should be compact. 1.01. What is the ratio of the Enrollment rate (%) of Bhutan in 2008 to that in 2012?
Make the answer very short. 0.9. What is the ratio of the Enrollment rate (%) in Lao PDR in 2008 to that in 2012?
Your answer should be very brief. 0.9. What is the ratio of the Enrollment rate (%) in Bhutan in 2009 to that in 2010?
Offer a terse response. 0.98. What is the ratio of the Enrollment rate (%) of Lao PDR in 2009 to that in 2010?
Offer a very short reply. 0.94. What is the ratio of the Enrollment rate (%) of Bhutan in 2009 to that in 2011?
Your answer should be compact. 0.97. What is the ratio of the Enrollment rate (%) in Lao PDR in 2009 to that in 2011?
Your answer should be very brief. 0.93. What is the ratio of the Enrollment rate (%) of Latin America(developing only) in 2009 to that in 2012?
Offer a terse response. 1.01. What is the ratio of the Enrollment rate (%) in Bhutan in 2009 to that in 2012?
Offer a very short reply. 0.95. What is the ratio of the Enrollment rate (%) in Bulgaria in 2009 to that in 2012?
Provide a succinct answer. 1.02. What is the ratio of the Enrollment rate (%) in Lao PDR in 2009 to that in 2012?
Your response must be concise. 0.93. What is the ratio of the Enrollment rate (%) of Latin America(developing only) in 2010 to that in 2011?
Offer a terse response. 1. What is the ratio of the Enrollment rate (%) of Bulgaria in 2010 to that in 2011?
Provide a short and direct response. 1.01. What is the ratio of the Enrollment rate (%) in Lao PDR in 2010 to that in 2011?
Keep it short and to the point. 0.99. What is the ratio of the Enrollment rate (%) of Latin America(developing only) in 2010 to that in 2012?
Keep it short and to the point. 1.01. What is the ratio of the Enrollment rate (%) of Bhutan in 2010 to that in 2012?
Offer a terse response. 0.97. What is the ratio of the Enrollment rate (%) of Bulgaria in 2010 to that in 2012?
Your answer should be very brief. 1.03. What is the ratio of the Enrollment rate (%) of Latin America(developing only) in 2011 to that in 2012?
Make the answer very short. 1.01. What is the ratio of the Enrollment rate (%) in Bhutan in 2011 to that in 2012?
Provide a short and direct response. 0.98. What is the ratio of the Enrollment rate (%) in Bulgaria in 2011 to that in 2012?
Provide a succinct answer. 1.02. What is the ratio of the Enrollment rate (%) of Lao PDR in 2011 to that in 2012?
Give a very brief answer. 0.99. What is the difference between the highest and the second highest Enrollment rate (%) in Latin America(developing only)?
Your answer should be compact. 1.07. What is the difference between the highest and the second highest Enrollment rate (%) in Bhutan?
Ensure brevity in your answer.  2. What is the difference between the highest and the second highest Enrollment rate (%) in Bulgaria?
Give a very brief answer. 0.61. What is the difference between the highest and the second highest Enrollment rate (%) of Lao PDR?
Offer a very short reply. 0.52. What is the difference between the highest and the lowest Enrollment rate (%) in Latin America(developing only)?
Make the answer very short. 2.1. What is the difference between the highest and the lowest Enrollment rate (%) in Bhutan?
Give a very brief answer. 13.65. What is the difference between the highest and the lowest Enrollment rate (%) of Bulgaria?
Give a very brief answer. 6.68. What is the difference between the highest and the lowest Enrollment rate (%) in Lao PDR?
Offer a terse response. 14.36. 